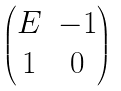<formula> <loc_0><loc_0><loc_500><loc_500>\begin{pmatrix} E & - 1 \\ 1 & 0 \end{pmatrix}</formula> 